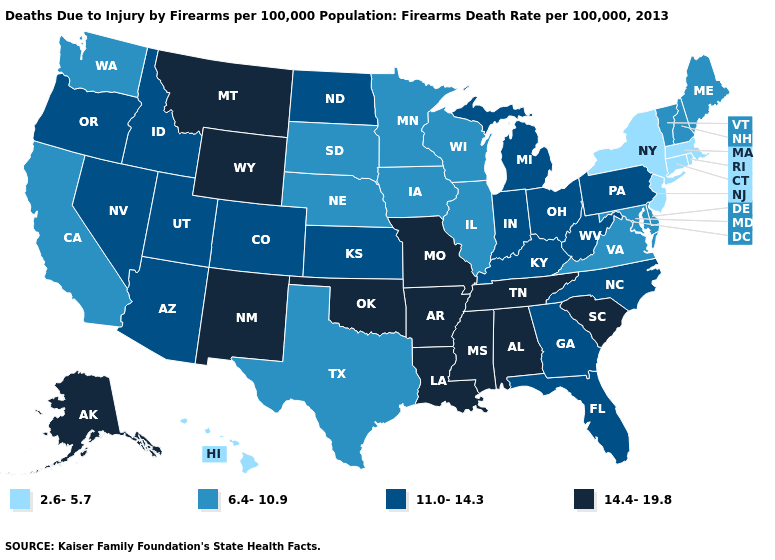What is the value of Louisiana?
Give a very brief answer. 14.4-19.8. What is the value of West Virginia?
Write a very short answer. 11.0-14.3. Does Kentucky have a higher value than West Virginia?
Be succinct. No. Does Georgia have the highest value in the South?
Answer briefly. No. Does California have the same value as Michigan?
Quick response, please. No. How many symbols are there in the legend?
Give a very brief answer. 4. What is the lowest value in the USA?
Quick response, please. 2.6-5.7. Does Missouri have the highest value in the MidWest?
Answer briefly. Yes. Which states have the lowest value in the MidWest?
Give a very brief answer. Illinois, Iowa, Minnesota, Nebraska, South Dakota, Wisconsin. Among the states that border Georgia , which have the lowest value?
Quick response, please. Florida, North Carolina. Which states have the lowest value in the USA?
Be succinct. Connecticut, Hawaii, Massachusetts, New Jersey, New York, Rhode Island. What is the value of Illinois?
Keep it brief. 6.4-10.9. What is the value of Alaska?
Write a very short answer. 14.4-19.8. What is the lowest value in the USA?
Be succinct. 2.6-5.7. 